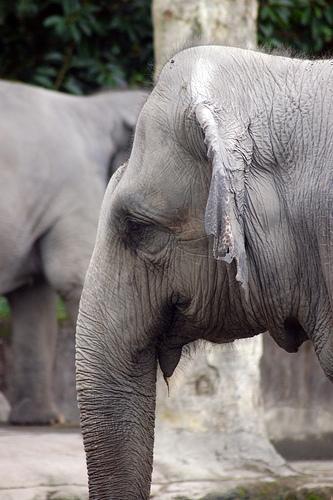How many elephants are visible?
Give a very brief answer. 2. 